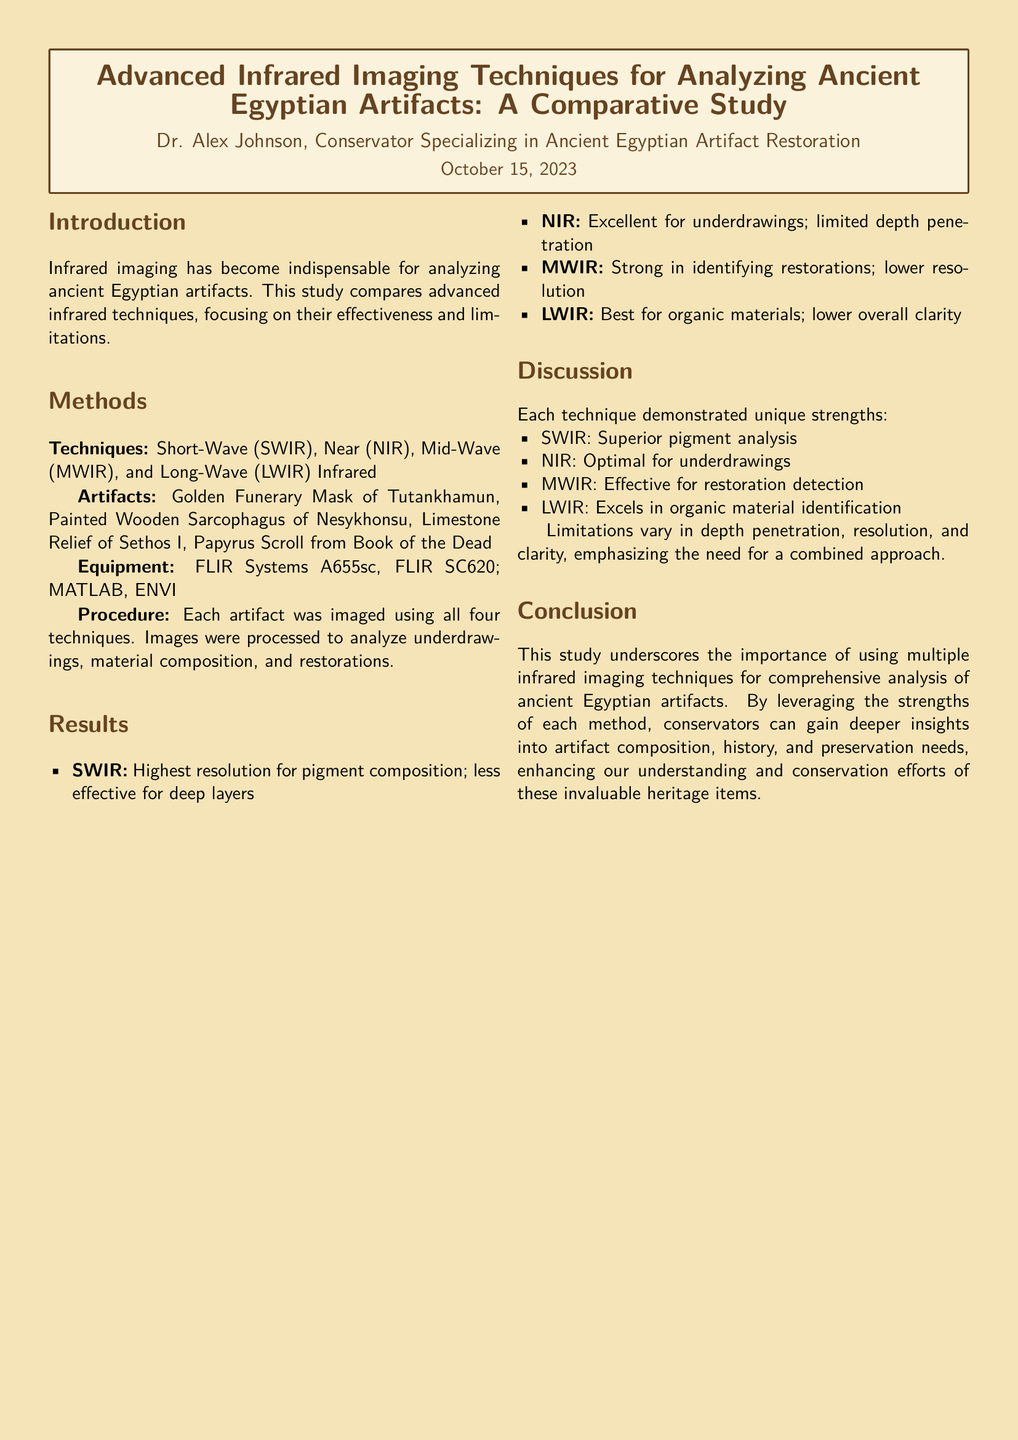What are the infrared techniques compared in the study? The study focuses on Short-Wave (SWIR), Near (NIR), Mid-Wave (MWIR), and Long-Wave (LWIR) Infrared techniques.
Answer: SWIR, NIR, MWIR, LWIR Who is the author of the lab report? The lab report is authored by Dr. Alex Johnson, a conservator specializing in ancient Egyptian artifact restoration.
Answer: Dr. Alex Johnson What artifact is known for its pigment analysis strength? The study highlights that SWIR is superior for pigment analysis.
Answer: SWIR Which infrared technique excels in identifying organic materials? The LWIR technique is noted for its effectiveness in organic material identification.
Answer: LWIR What is the date of publication for this lab report? The lab report was published on October 15, 2023.
Answer: October 15, 2023 What is the primary focus of the lab report? The primary focus of the report is to analyze the effectiveness and limitations of various infrared imaging techniques.
Answer: Effectiveness and limitations of infrared imaging techniques How many artifacts were analyzed in the study? The study analyzed a total of four artifacts.
Answer: Four artifacts What is the conclusion drawn from the comparative study? The conclusion emphasizes the importance of using multiple infrared imaging techniques for comprehensive artifact analysis.
Answer: Importance of using multiple techniques 